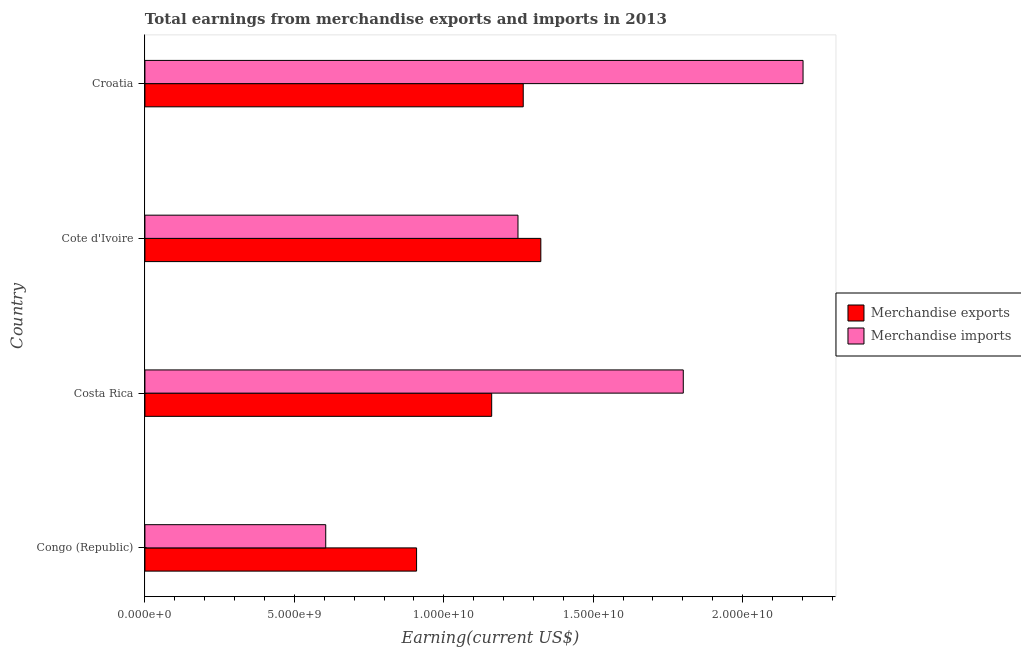How many different coloured bars are there?
Your answer should be compact. 2. What is the label of the 2nd group of bars from the top?
Offer a terse response. Cote d'Ivoire. What is the earnings from merchandise imports in Costa Rica?
Give a very brief answer. 1.80e+1. Across all countries, what is the maximum earnings from merchandise imports?
Make the answer very short. 2.20e+1. Across all countries, what is the minimum earnings from merchandise exports?
Give a very brief answer. 9.09e+09. In which country was the earnings from merchandise exports maximum?
Offer a terse response. Cote d'Ivoire. In which country was the earnings from merchandise exports minimum?
Ensure brevity in your answer.  Congo (Republic). What is the total earnings from merchandise imports in the graph?
Your answer should be compact. 5.86e+1. What is the difference between the earnings from merchandise imports in Costa Rica and that in Cote d'Ivoire?
Offer a very short reply. 5.53e+09. What is the difference between the earnings from merchandise exports in Croatia and the earnings from merchandise imports in Congo (Republic)?
Keep it short and to the point. 6.61e+09. What is the average earnings from merchandise exports per country?
Your answer should be very brief. 1.16e+1. What is the difference between the earnings from merchandise exports and earnings from merchandise imports in Croatia?
Provide a succinct answer. -9.36e+09. In how many countries, is the earnings from merchandise exports greater than 19000000000 US$?
Offer a very short reply. 0. What is the ratio of the earnings from merchandise exports in Costa Rica to that in Cote d'Ivoire?
Provide a succinct answer. 0.88. What is the difference between the highest and the second highest earnings from merchandise exports?
Your answer should be very brief. 5.89e+08. What is the difference between the highest and the lowest earnings from merchandise imports?
Offer a very short reply. 1.60e+1. In how many countries, is the earnings from merchandise exports greater than the average earnings from merchandise exports taken over all countries?
Make the answer very short. 2. How many countries are there in the graph?
Provide a short and direct response. 4. How are the legend labels stacked?
Offer a terse response. Vertical. What is the title of the graph?
Offer a terse response. Total earnings from merchandise exports and imports in 2013. Does "Rural Population" appear as one of the legend labels in the graph?
Keep it short and to the point. No. What is the label or title of the X-axis?
Provide a short and direct response. Earning(current US$). What is the label or title of the Y-axis?
Ensure brevity in your answer.  Country. What is the Earning(current US$) in Merchandise exports in Congo (Republic)?
Provide a short and direct response. 9.09e+09. What is the Earning(current US$) of Merchandise imports in Congo (Republic)?
Offer a very short reply. 6.05e+09. What is the Earning(current US$) in Merchandise exports in Costa Rica?
Your answer should be compact. 1.16e+1. What is the Earning(current US$) of Merchandise imports in Costa Rica?
Ensure brevity in your answer.  1.80e+1. What is the Earning(current US$) of Merchandise exports in Cote d'Ivoire?
Provide a succinct answer. 1.32e+1. What is the Earning(current US$) of Merchandise imports in Cote d'Ivoire?
Provide a short and direct response. 1.25e+1. What is the Earning(current US$) in Merchandise exports in Croatia?
Provide a short and direct response. 1.27e+1. What is the Earning(current US$) in Merchandise imports in Croatia?
Your answer should be very brief. 2.20e+1. Across all countries, what is the maximum Earning(current US$) of Merchandise exports?
Provide a succinct answer. 1.32e+1. Across all countries, what is the maximum Earning(current US$) of Merchandise imports?
Offer a very short reply. 2.20e+1. Across all countries, what is the minimum Earning(current US$) in Merchandise exports?
Your answer should be very brief. 9.09e+09. Across all countries, what is the minimum Earning(current US$) of Merchandise imports?
Offer a very short reply. 6.05e+09. What is the total Earning(current US$) of Merchandise exports in the graph?
Provide a short and direct response. 4.66e+1. What is the total Earning(current US$) in Merchandise imports in the graph?
Give a very brief answer. 5.86e+1. What is the difference between the Earning(current US$) in Merchandise exports in Congo (Republic) and that in Costa Rica?
Your answer should be very brief. -2.51e+09. What is the difference between the Earning(current US$) of Merchandise imports in Congo (Republic) and that in Costa Rica?
Provide a succinct answer. -1.20e+1. What is the difference between the Earning(current US$) in Merchandise exports in Congo (Republic) and that in Cote d'Ivoire?
Ensure brevity in your answer.  -4.16e+09. What is the difference between the Earning(current US$) in Merchandise imports in Congo (Republic) and that in Cote d'Ivoire?
Your answer should be very brief. -6.43e+09. What is the difference between the Earning(current US$) of Merchandise exports in Congo (Republic) and that in Croatia?
Your answer should be compact. -3.57e+09. What is the difference between the Earning(current US$) in Merchandise imports in Congo (Republic) and that in Croatia?
Offer a terse response. -1.60e+1. What is the difference between the Earning(current US$) in Merchandise exports in Costa Rica and that in Cote d'Ivoire?
Your answer should be very brief. -1.64e+09. What is the difference between the Earning(current US$) in Merchandise imports in Costa Rica and that in Cote d'Ivoire?
Your answer should be compact. 5.53e+09. What is the difference between the Earning(current US$) in Merchandise exports in Costa Rica and that in Croatia?
Your answer should be very brief. -1.06e+09. What is the difference between the Earning(current US$) in Merchandise imports in Costa Rica and that in Croatia?
Your answer should be compact. -4.01e+09. What is the difference between the Earning(current US$) in Merchandise exports in Cote d'Ivoire and that in Croatia?
Make the answer very short. 5.89e+08. What is the difference between the Earning(current US$) of Merchandise imports in Cote d'Ivoire and that in Croatia?
Provide a short and direct response. -9.54e+09. What is the difference between the Earning(current US$) in Merchandise exports in Congo (Republic) and the Earning(current US$) in Merchandise imports in Costa Rica?
Make the answer very short. -8.92e+09. What is the difference between the Earning(current US$) of Merchandise exports in Congo (Republic) and the Earning(current US$) of Merchandise imports in Cote d'Ivoire?
Make the answer very short. -3.39e+09. What is the difference between the Earning(current US$) in Merchandise exports in Congo (Republic) and the Earning(current US$) in Merchandise imports in Croatia?
Provide a short and direct response. -1.29e+1. What is the difference between the Earning(current US$) of Merchandise exports in Costa Rica and the Earning(current US$) of Merchandise imports in Cote d'Ivoire?
Keep it short and to the point. -8.80e+08. What is the difference between the Earning(current US$) in Merchandise exports in Costa Rica and the Earning(current US$) in Merchandise imports in Croatia?
Give a very brief answer. -1.04e+1. What is the difference between the Earning(current US$) of Merchandise exports in Cote d'Ivoire and the Earning(current US$) of Merchandise imports in Croatia?
Your answer should be compact. -8.77e+09. What is the average Earning(current US$) of Merchandise exports per country?
Your response must be concise. 1.16e+1. What is the average Earning(current US$) of Merchandise imports per country?
Your response must be concise. 1.46e+1. What is the difference between the Earning(current US$) in Merchandise exports and Earning(current US$) in Merchandise imports in Congo (Republic)?
Give a very brief answer. 3.04e+09. What is the difference between the Earning(current US$) in Merchandise exports and Earning(current US$) in Merchandise imports in Costa Rica?
Provide a succinct answer. -6.41e+09. What is the difference between the Earning(current US$) in Merchandise exports and Earning(current US$) in Merchandise imports in Cote d'Ivoire?
Your response must be concise. 7.64e+08. What is the difference between the Earning(current US$) in Merchandise exports and Earning(current US$) in Merchandise imports in Croatia?
Provide a succinct answer. -9.36e+09. What is the ratio of the Earning(current US$) of Merchandise exports in Congo (Republic) to that in Costa Rica?
Keep it short and to the point. 0.78. What is the ratio of the Earning(current US$) of Merchandise imports in Congo (Republic) to that in Costa Rica?
Provide a short and direct response. 0.34. What is the ratio of the Earning(current US$) in Merchandise exports in Congo (Republic) to that in Cote d'Ivoire?
Ensure brevity in your answer.  0.69. What is the ratio of the Earning(current US$) of Merchandise imports in Congo (Republic) to that in Cote d'Ivoire?
Your response must be concise. 0.48. What is the ratio of the Earning(current US$) of Merchandise exports in Congo (Republic) to that in Croatia?
Your answer should be compact. 0.72. What is the ratio of the Earning(current US$) in Merchandise imports in Congo (Republic) to that in Croatia?
Provide a succinct answer. 0.27. What is the ratio of the Earning(current US$) of Merchandise exports in Costa Rica to that in Cote d'Ivoire?
Your response must be concise. 0.88. What is the ratio of the Earning(current US$) of Merchandise imports in Costa Rica to that in Cote d'Ivoire?
Keep it short and to the point. 1.44. What is the ratio of the Earning(current US$) of Merchandise exports in Costa Rica to that in Croatia?
Offer a terse response. 0.92. What is the ratio of the Earning(current US$) of Merchandise imports in Costa Rica to that in Croatia?
Ensure brevity in your answer.  0.82. What is the ratio of the Earning(current US$) of Merchandise exports in Cote d'Ivoire to that in Croatia?
Your answer should be very brief. 1.05. What is the ratio of the Earning(current US$) in Merchandise imports in Cote d'Ivoire to that in Croatia?
Keep it short and to the point. 0.57. What is the difference between the highest and the second highest Earning(current US$) of Merchandise exports?
Your response must be concise. 5.89e+08. What is the difference between the highest and the second highest Earning(current US$) in Merchandise imports?
Ensure brevity in your answer.  4.01e+09. What is the difference between the highest and the lowest Earning(current US$) of Merchandise exports?
Make the answer very short. 4.16e+09. What is the difference between the highest and the lowest Earning(current US$) in Merchandise imports?
Make the answer very short. 1.60e+1. 